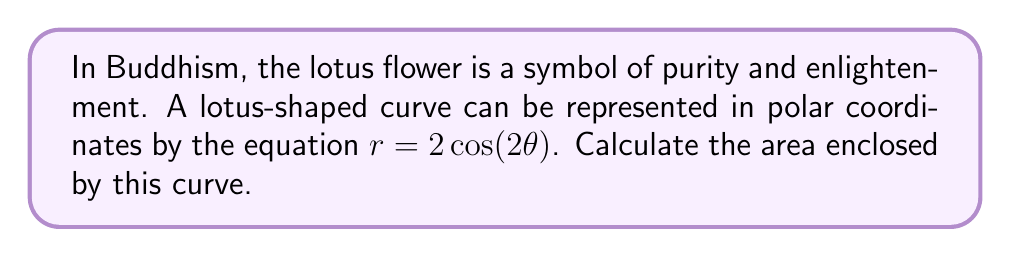Can you solve this math problem? To find the area enclosed by the lotus-shaped curve, we'll follow these steps:

1. Recall the formula for area in polar coordinates:
   $$ A = \frac{1}{2} \int_0^{2\pi} r^2 d\theta $$

2. Substitute the given equation $r = 2\cos(2\theta)$ into the formula:
   $$ A = \frac{1}{2} \int_0^{2\pi} (2\cos(2\theta))^2 d\theta $$

3. Simplify the integrand:
   $$ A = \frac{1}{2} \int_0^{2\pi} 4\cos^2(2\theta) d\theta $$

4. Use the trigonometric identity $\cos^2(x) = \frac{1}{2}(1 + \cos(2x))$:
   $$ A = \frac{1}{2} \int_0^{2\pi} 4 \cdot \frac{1}{2}(1 + \cos(4\theta)) d\theta $$
   $$ A = \int_0^{2\pi} (1 + \cos(4\theta)) d\theta $$

5. Integrate:
   $$ A = [\theta + \frac{1}{4}\sin(4\theta)]_0^{2\pi} $$

6. Evaluate the definite integral:
   $$ A = (2\pi + 0) - (0 + 0) = 2\pi $$

Therefore, the area enclosed by the lotus-shaped curve is $2\pi$ square units.
Answer: $2\pi$ square units 